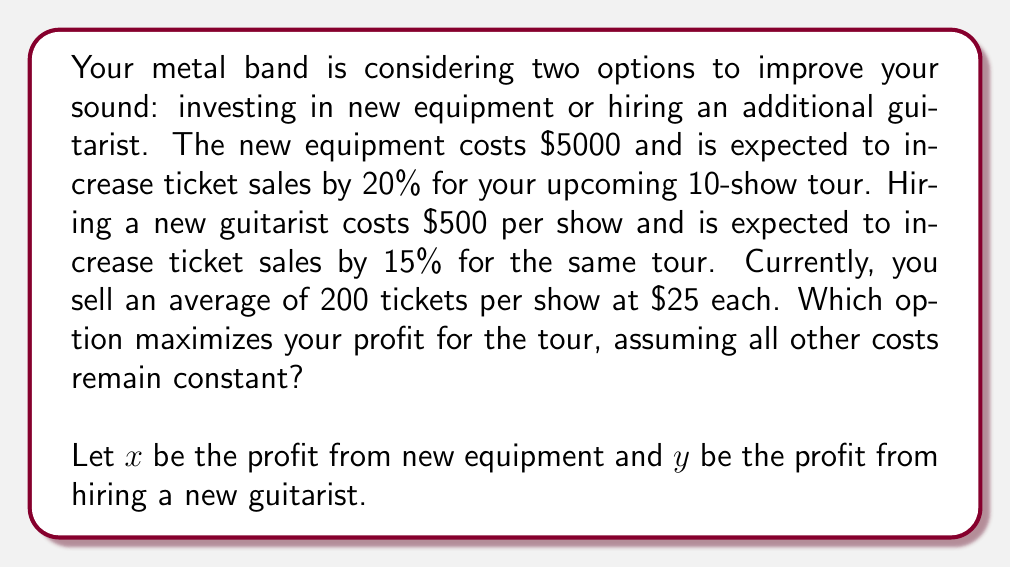Give your solution to this math problem. Let's break this down step-by-step:

1. Calculate current revenue per show:
   $200 \text{ tickets} \times \$25 = \$5000$ per show

2. Calculate revenue for 10 shows:
   $\$5000 \times 10 = \$50,000$ total revenue

3. For new equipment option:
   a. Increased ticket sales: $200 \times 1.20 = 240$ tickets per show
   b. New revenue per show: $240 \times \$25 = \$6000$
   c. Total revenue for 10 shows: $\$6000 \times 10 = \$60,000$
   d. Profit: $x = \$60,000 - \$50,000 - \$5000 = \$5000$

4. For new guitarist option:
   a. Increased ticket sales: $200 \times 1.15 = 230$ tickets per show
   b. New revenue per show: $230 \times \$25 = \$5750$
   c. Total revenue for 10 shows: $\$5750 \times 10 = \$57,500$
   d. Cost of guitarist for 10 shows: $\$500 \times 10 = \$5000$
   e. Profit: $y = \$57,500 - \$50,000 - \$5000 = \$2500$

5. Compare profits:
   $x = \$5000 > y = \$2500$

Therefore, investing in new equipment maximizes profit for the tour.
Answer: Investing in new equipment maximizes profit, yielding $5000 more than the current setup, compared to $2500 for hiring a new guitarist. 